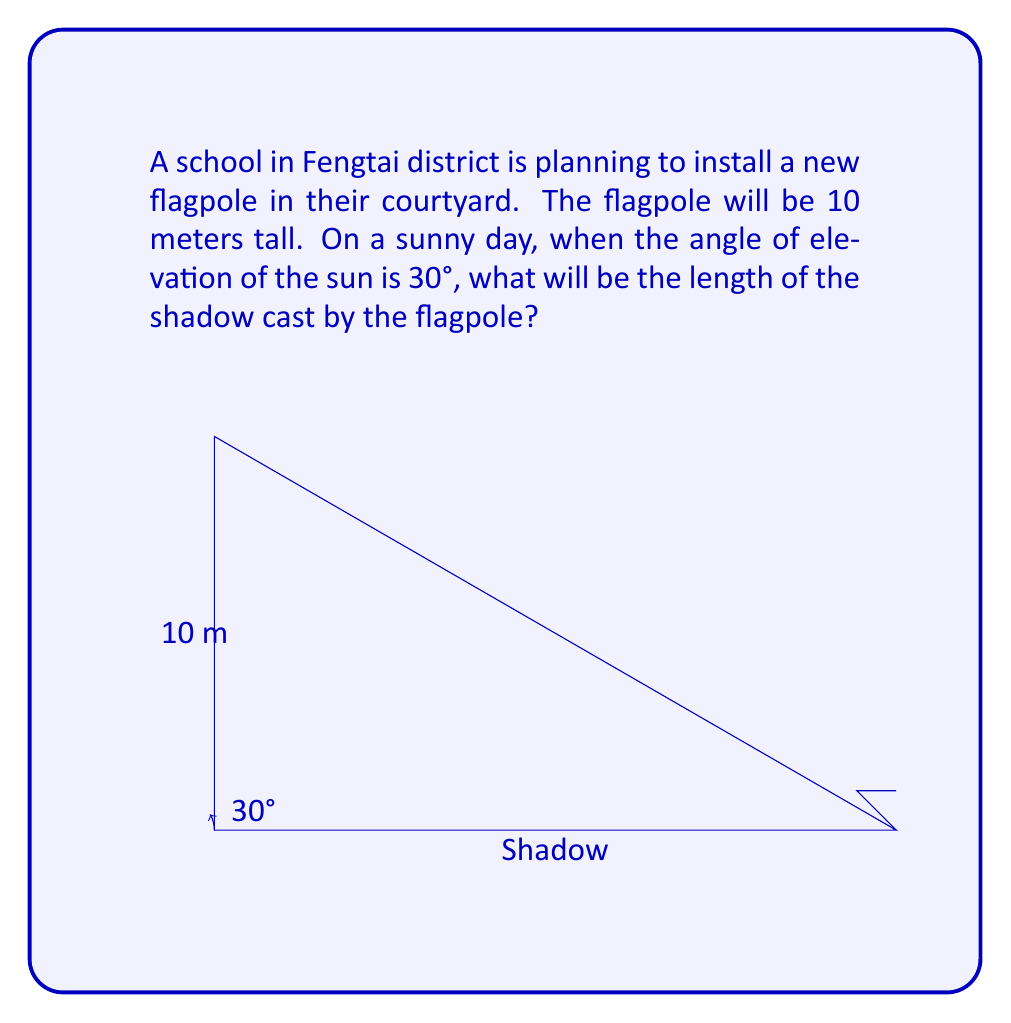Solve this math problem. To solve this problem, we'll use trigonometry. Let's break it down step-by-step:

1) In a right-angled triangle formed by the flagpole, its shadow, and the sun's rays, we know:
   - The adjacent side (height of the flagpole) = 10 meters
   - The angle of elevation of the sun = 30°
   - We need to find the opposite side (length of the shadow)

2) The trigonometric ratio that relates the adjacent side to the opposite side is the tangent function:

   $$\tan \theta = \frac{\text{opposite}}{\text{adjacent}}$$

3) In our case:

   $$\tan 30° = \frac{\text{flagpole height}}{\text{shadow length}}$$

4) We know that $\tan 30° = \frac{1}{\sqrt{3}}$. Let's call the shadow length $x$. So we have:

   $$\frac{1}{\sqrt{3}} = \frac{10}{x}$$

5) Cross multiply:

   $$x \cdot \frac{1}{\sqrt{3}} = 10$$

6) Solve for $x$:

   $$x = 10 \cdot \sqrt{3} \approx 17.32$$

Therefore, the shadow cast by the flagpole will be approximately 17.32 meters long.
Answer: The length of the shadow cast by the 10-meter flagpole when the sun's angle of elevation is 30° is $10\sqrt{3} \approx 17.32$ meters. 